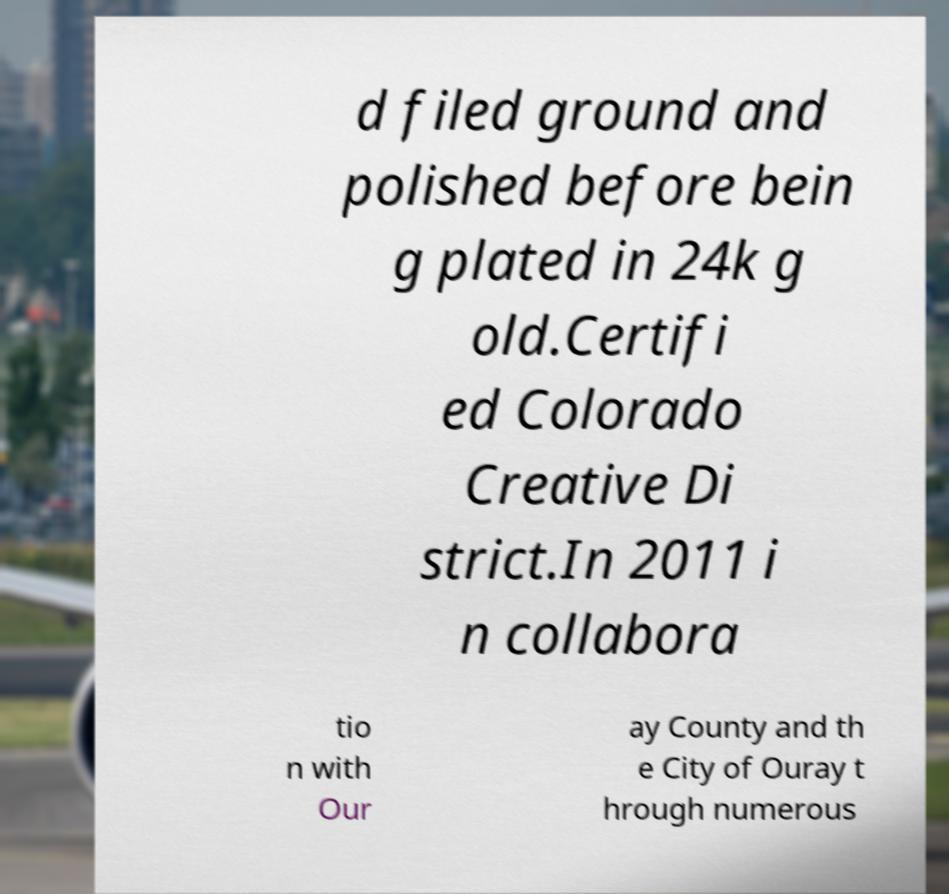Please identify and transcribe the text found in this image. d filed ground and polished before bein g plated in 24k g old.Certifi ed Colorado Creative Di strict.In 2011 i n collabora tio n with Our ay County and th e City of Ouray t hrough numerous 